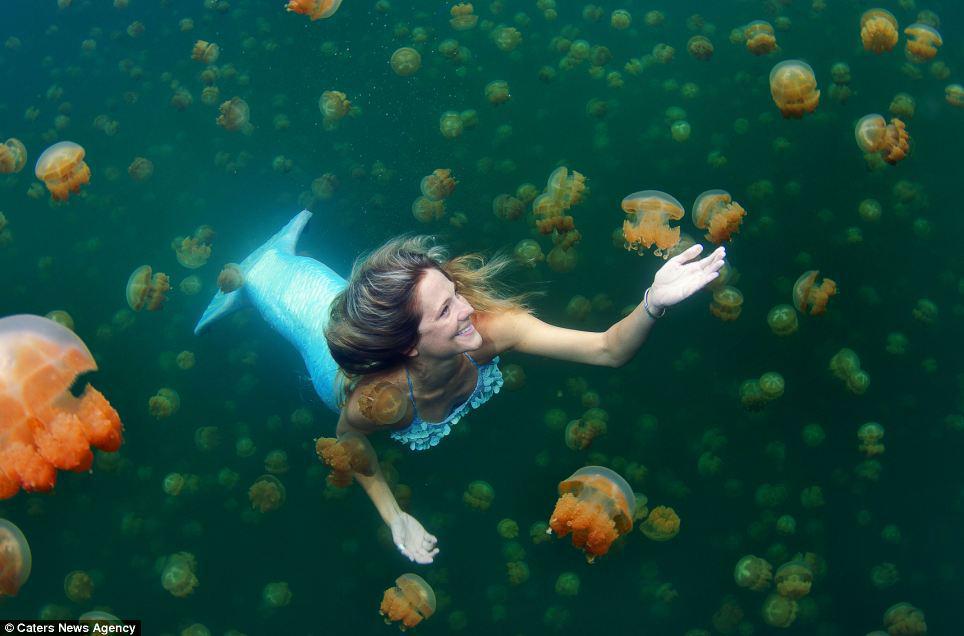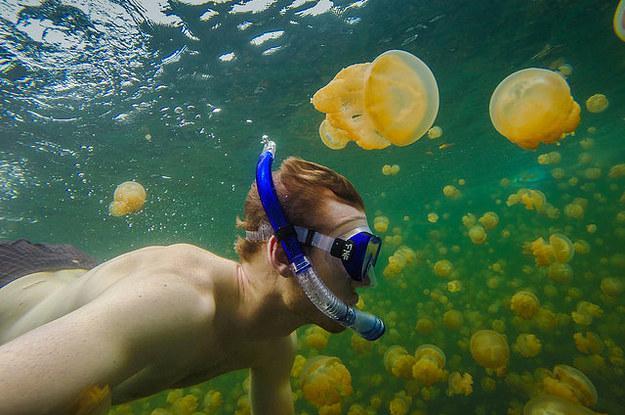The first image is the image on the left, the second image is the image on the right. Examine the images to the left and right. Is the description "A diver in a black wetsuit is near at least one pale beige mushroom-look jellyfish." accurate? Answer yes or no. No. 